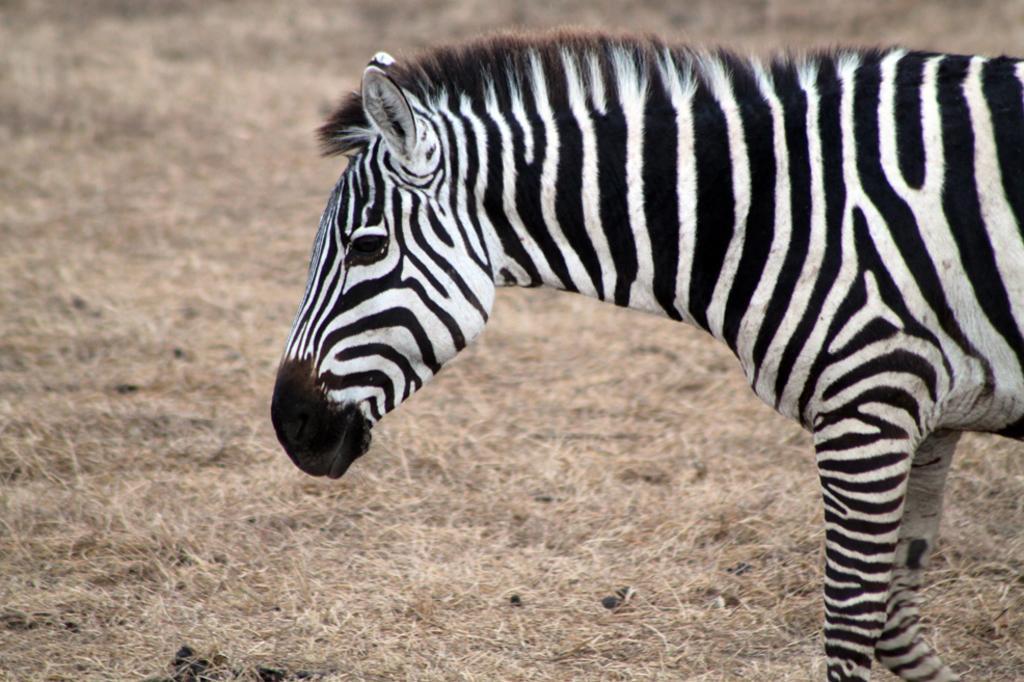Describe this image in one or two sentences. In the picture I can see zebra and some grass. 